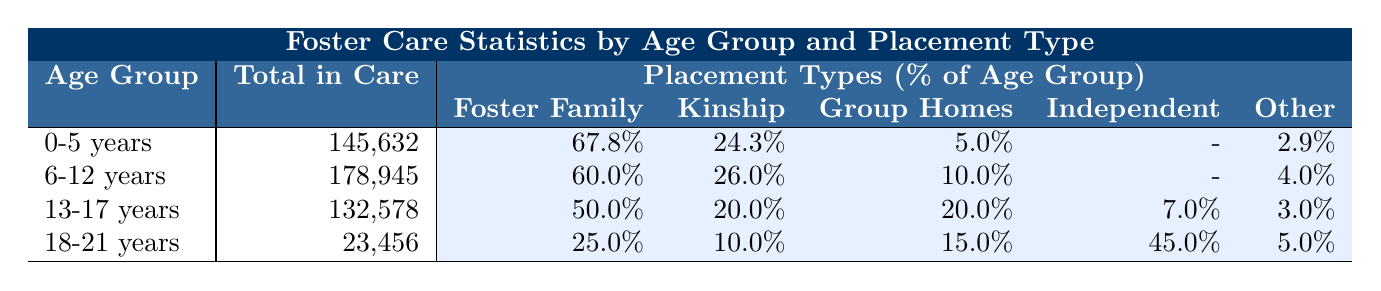What's the total number of children in care aged 0-5 years? The table shows that the total number of children in care for the age group 0-5 years is listed directly under that age category, which is 145,632.
Answer: 145,632 What percentage of 6-12 year olds are in foster family homes? Looking at the placement types for the 6-12 years age group, the percentage of children in foster family homes is indicated as 60.0%.
Answer: 60.0% Which placement type has the highest percentage for the 13-17 years age group? In the 13-17 years age group, the highest percentages for placement types are compared: foster family homes (50.0%), kinship care (20.0%), group homes (20.0%), independent living (7.0%), and other (3.0%). Foster family homes have the highest at 50.0%.
Answer: Foster Family Homes What is the total percentage of children in care for the age group 18-21 years who are in either group homes or independent living? For the 18-21 years age group, the percentages for group homes and independent living are combined. Group homes have 15.0%, and independent living has 45.0%. The total is 15.0% + 45.0% = 60.0%.
Answer: 60.0% Is there a placement type that has the same percentage for both 13-17 year olds and the 18-21 year olds? By examining the percentages, the placement types for 13-17 years show group homes and kinship care at 20.0% and 20.0%. For the 18-21 year olds, kinship care is at 10.0%, and group homes are at 15.0%. No placement types match the same percentage for both age groups.
Answer: No What is the average percentage of children in foster family homes across all age groups? To find the average, the percentages for foster family homes from each age group are summed: 67.8% + 60.0% + 50.0% + 25.0% = 202.8%. Then, divide by the number of age groups (4) to calculate the average: 202.8% / 4 = 50.7%.
Answer: 50.7% How many more children are in kinship care than in group homes for the age group 0-5 years? For the 0-5 years age group, the number of children in kinship care is 35,421 and in group homes is 7,281. The difference is 35,421 - 7,281 = 28,140, indicating there are 28,140 more children in kinship care.
Answer: 28,140 In which age group do the majority of children live in independent living? Reviewing the table, independent living exists only in the 13-17 years and 18-21 years age groups. In the 18-21 years age group, independent living has 45.0%, which is higher than 7.0% in the 13-17 years age group. Thus, the majority of children in independent living are in the 18-21 years age group.
Answer: 18-21 years What is the ratio of children in foster family homes to those in 'other' placements for the 6-12 years age group? For the 6-12 years age group, there are 107,367 children in foster family homes and 7,158 in 'other' placements. The ratio is calculated as 107,367:7,158, which simplifies roughly to 15:1.
Answer: 15:1 